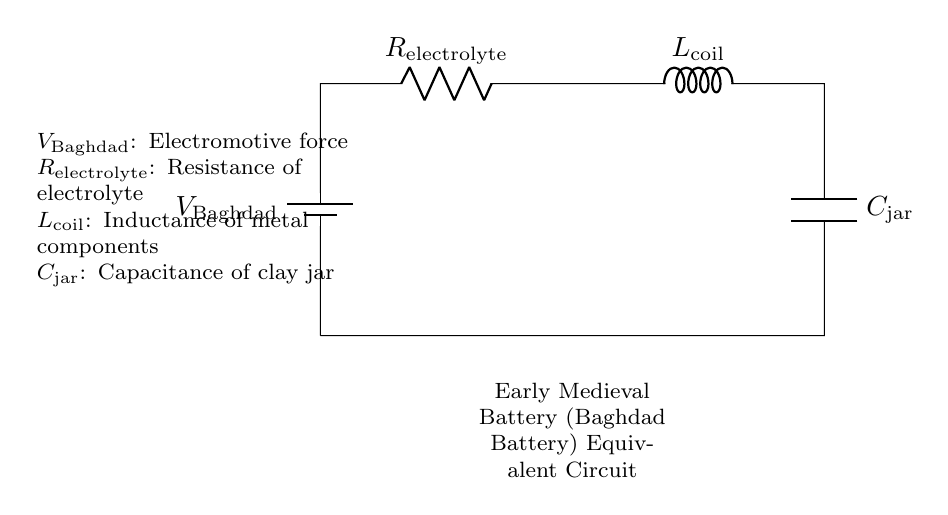What is the voltage source in this circuit? The voltage source in the circuit is labeled as V_Baghdad, which indicates its role as the electromotive force. It provides the necessary potential difference for the operation of the circuit.
Answer: V_Baghdad What component represents resistance in the circuit? The component that represents resistance is labeled as R_electrolyte. It signifies the resistance presented by the electrolyte, which is essential for controlling the current flow in the circuit.
Answer: R_electrolyte Which component represents inductance? The component that represents inductance in the circuit is L_coil, indicating the inductance associated with metal components within the battery setup.
Answer: L_coil How many components are in series in this circuit? The circuit consists of four components that are connected in series: a voltage source, a resistor, an inductor, and a capacitor. This is crucial for determining the overall behavior of the circuit during the charge-discharge cycle.
Answer: 4 What type of circuit is represented? The circuit is represented as a series RLC circuit, which consists of a resistor, an inductor, and a capacitor connected in series. This type of circuit is important for analyzing the dynamic behavior of the early medieval battery.
Answer: Series RLC circuit What does the capacitor represent in this circuit? The capacitor, labeled as C_jar, represents the capacitance of the clay jar used in the battery. Its role is crucial in storing electric charge during the operation of the circuit.
Answer: C_jar What is the effect of the inductance in this circuit during discharging? The inductance, represented by L_coil, introduces a delay in the current flow due to its property of opposing changes in current. This creates a time-dependent behavior as the circuit discharges, influencing the overall dynamics.
Answer: Delay in current flow 